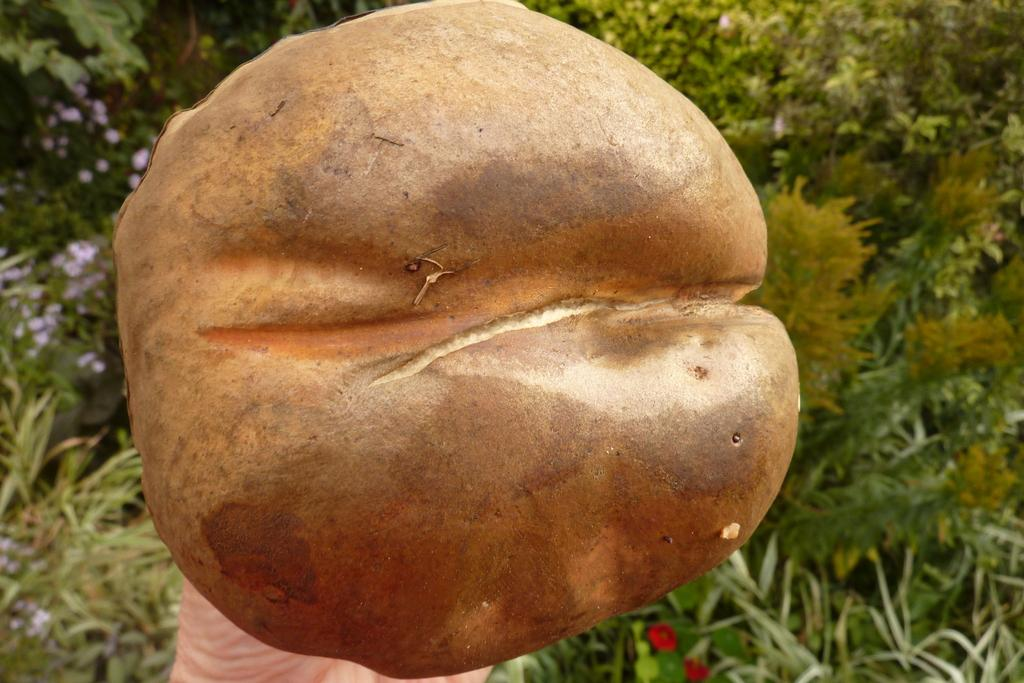What is the main subject of the image? There is a person in the image. What is the person holding in the image? The person is holding something that resembles groundnuts. What can be seen in the background of the image? There are trees and plants in the background of the image. What type of lipstick is the person wearing in the image? There is no lipstick or any indication of the person wearing lipstick in the image. 